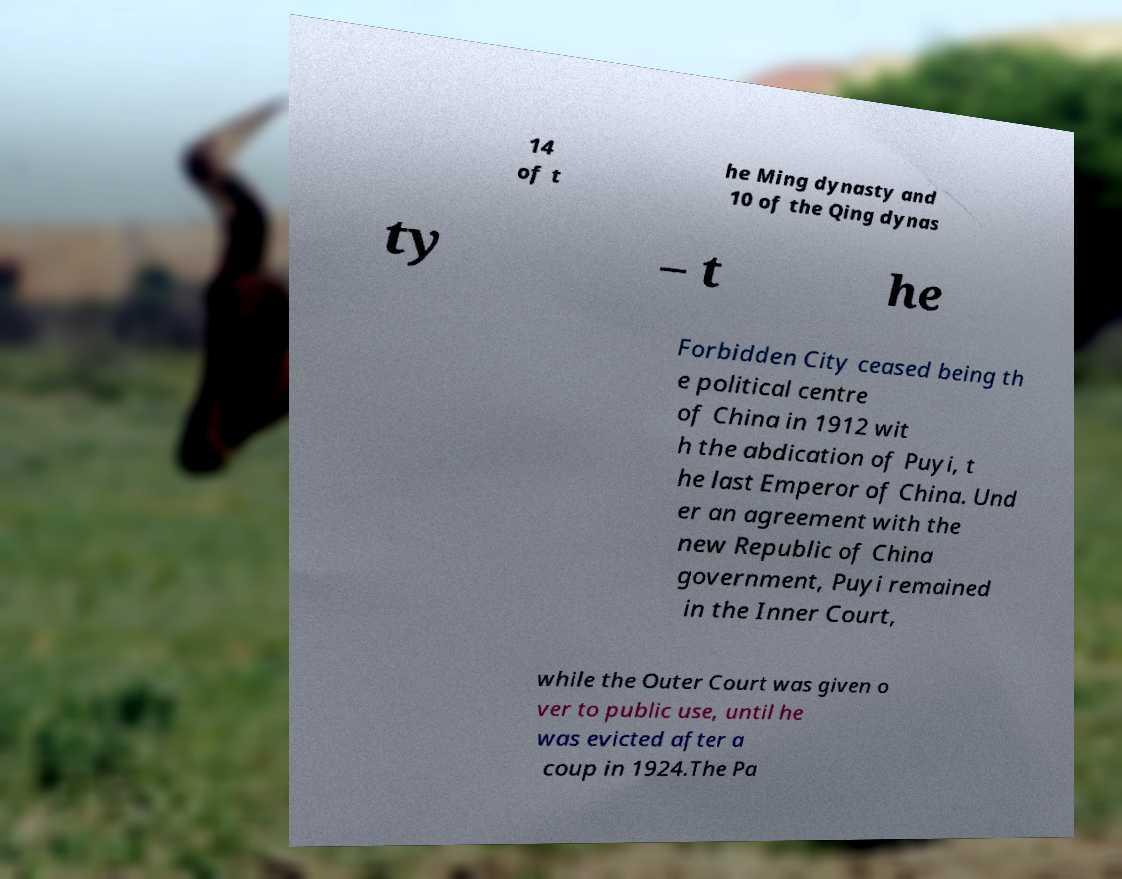Please identify and transcribe the text found in this image. 14 of t he Ming dynasty and 10 of the Qing dynas ty – t he Forbidden City ceased being th e political centre of China in 1912 wit h the abdication of Puyi, t he last Emperor of China. Und er an agreement with the new Republic of China government, Puyi remained in the Inner Court, while the Outer Court was given o ver to public use, until he was evicted after a coup in 1924.The Pa 